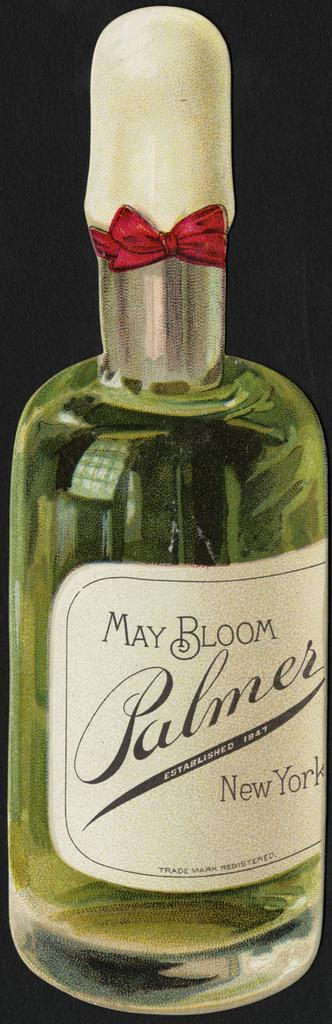<image>
Share a concise interpretation of the image provided. A bottle for May Bloom Palmers from New York. 